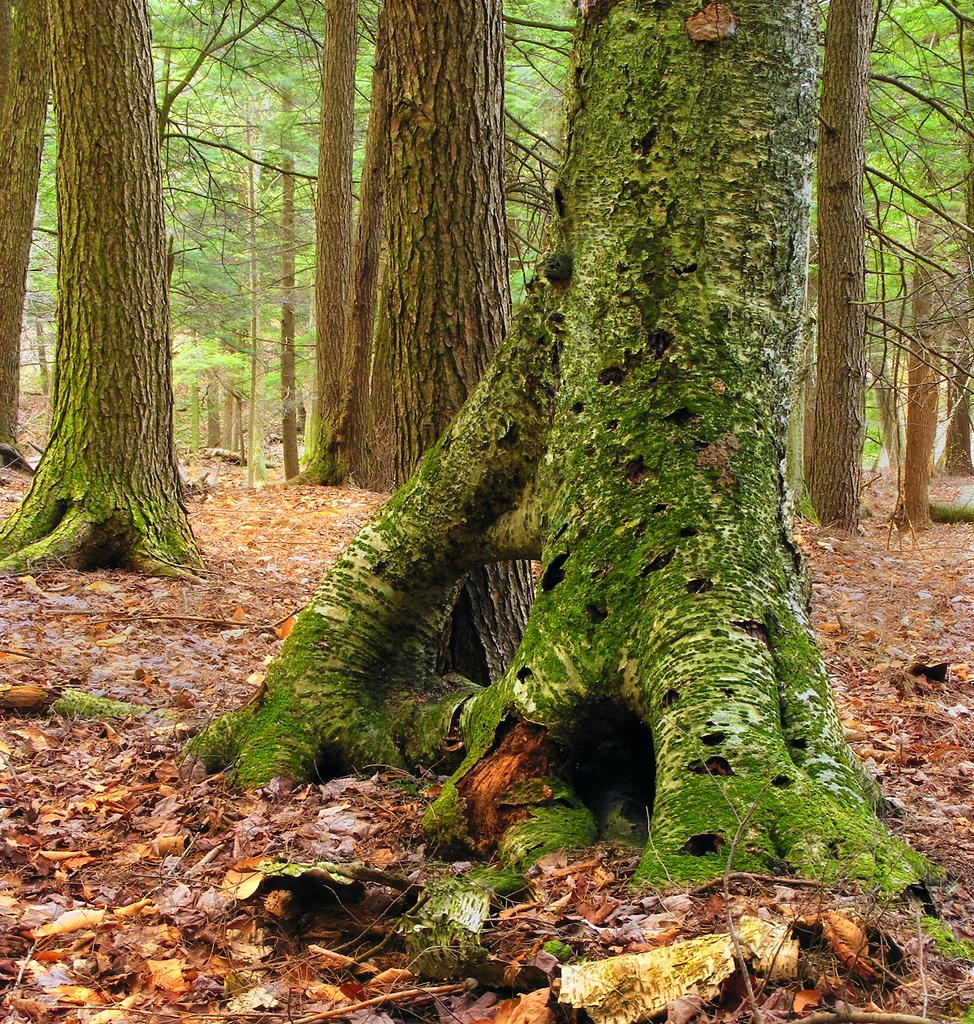What is covering the ground in the image? There are dry leaves on the ground in the image. What can be seen standing on the ground in the image? There are tree trunks in the image. What is visible in the background of the image? There are trees in the background of the image. Can you see any tomatoes growing on the trees in the image? There are no tomatoes present in the image; it features dry leaves on the ground and tree trunks. Is there a sofa visible in the image? There is no sofa present in the image. 